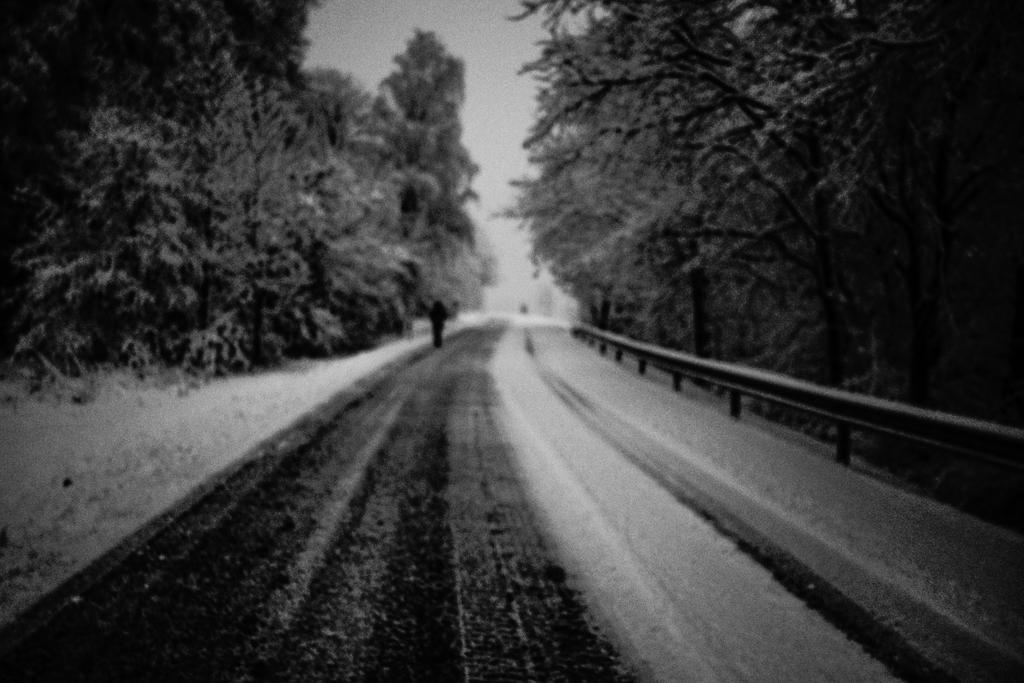What is the main feature of the image? There is a road in the image. What can be seen on either side of the road? Trees are present on either side of the road. Is there anyone visible on the road? Yes, there is a person on the road. What type of soup is being served at the band's performance in the image? There is no soup or band present in the image; it only features a road with trees and a person. 